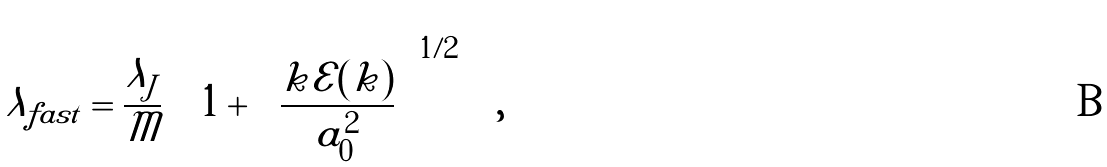<formula> <loc_0><loc_0><loc_500><loc_500>\lambda _ { f a s t } = \frac { \lambda _ { J } } { \mathcal { M } } \left ( 1 + \left ( \frac { k \mathcal { E } ( k ) } { a _ { 0 } ^ { 2 } } \right ) ^ { 1 / 2 } \right ) ,</formula> 